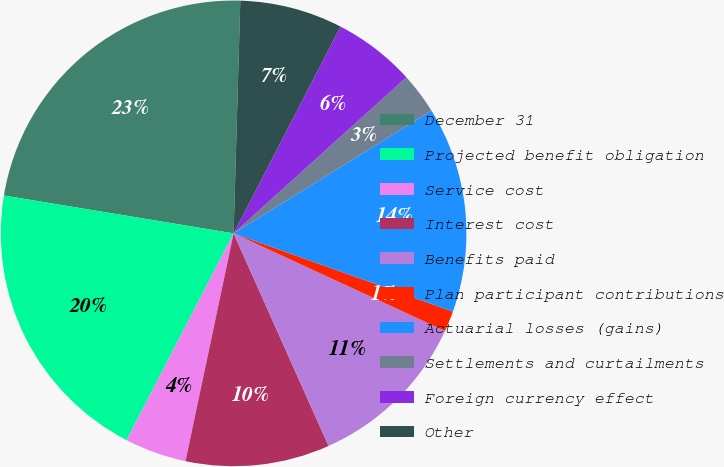Convert chart to OTSL. <chart><loc_0><loc_0><loc_500><loc_500><pie_chart><fcel>December 31<fcel>Projected benefit obligation<fcel>Service cost<fcel>Interest cost<fcel>Benefits paid<fcel>Plan participant contributions<fcel>Actuarial losses (gains)<fcel>Settlements and curtailments<fcel>Foreign currency effect<fcel>Other<nl><fcel>22.86%<fcel>20.0%<fcel>4.29%<fcel>10.0%<fcel>11.43%<fcel>1.43%<fcel>14.29%<fcel>2.86%<fcel>5.71%<fcel>7.14%<nl></chart> 